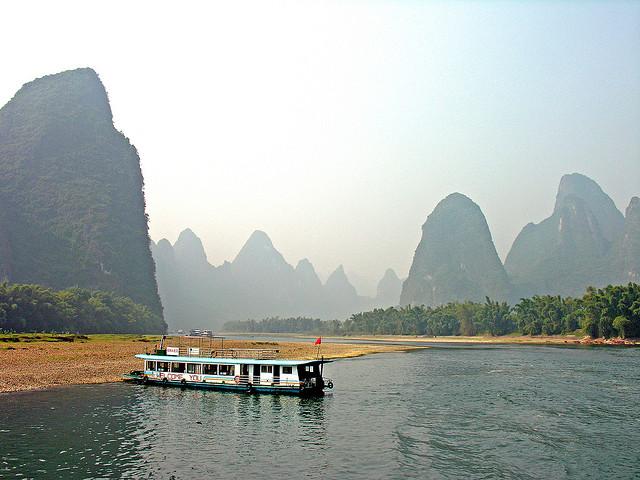Why is the boat stopped?
Short answer required. Let people off. What kind of boat is this?
Write a very short answer. Ferry. How many mountain tops can you count?
Short answer required. 10. 